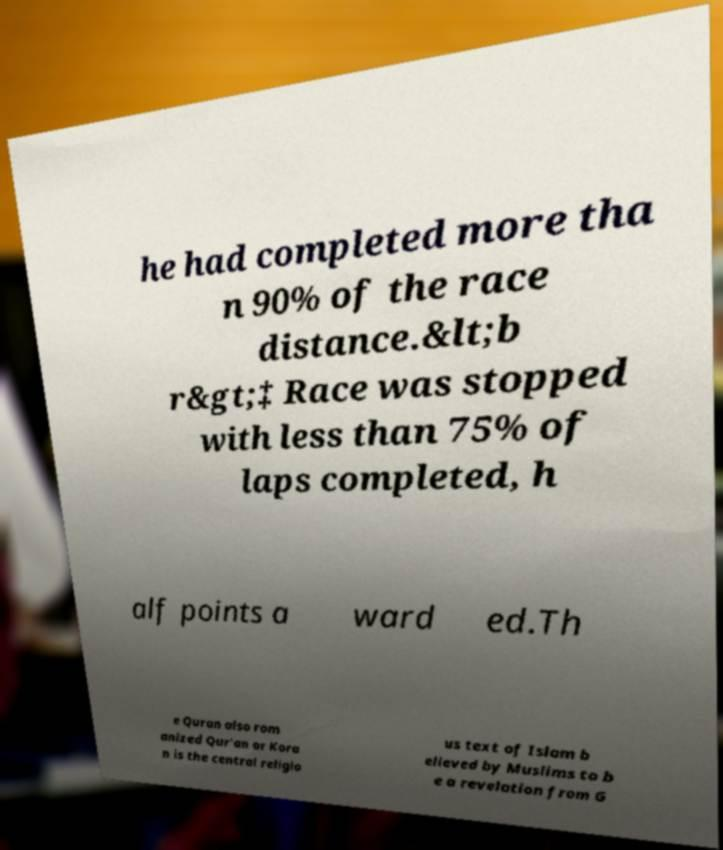What messages or text are displayed in this image? I need them in a readable, typed format. he had completed more tha n 90% of the race distance.&lt;b r&gt;‡ Race was stopped with less than 75% of laps completed, h alf points a ward ed.Th e Quran also rom anized Qur'an or Kora n is the central religio us text of Islam b elieved by Muslims to b e a revelation from G 